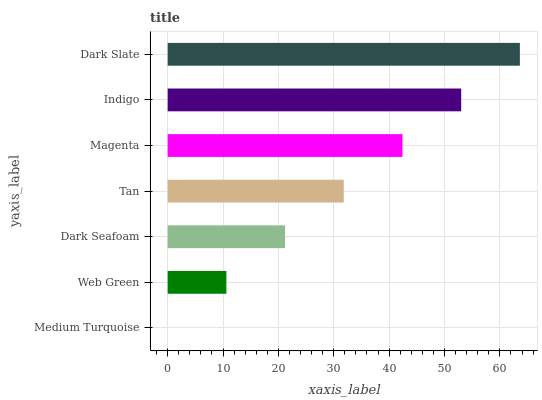Is Medium Turquoise the minimum?
Answer yes or no. Yes. Is Dark Slate the maximum?
Answer yes or no. Yes. Is Web Green the minimum?
Answer yes or no. No. Is Web Green the maximum?
Answer yes or no. No. Is Web Green greater than Medium Turquoise?
Answer yes or no. Yes. Is Medium Turquoise less than Web Green?
Answer yes or no. Yes. Is Medium Turquoise greater than Web Green?
Answer yes or no. No. Is Web Green less than Medium Turquoise?
Answer yes or no. No. Is Tan the high median?
Answer yes or no. Yes. Is Tan the low median?
Answer yes or no. Yes. Is Indigo the high median?
Answer yes or no. No. Is Dark Slate the low median?
Answer yes or no. No. 